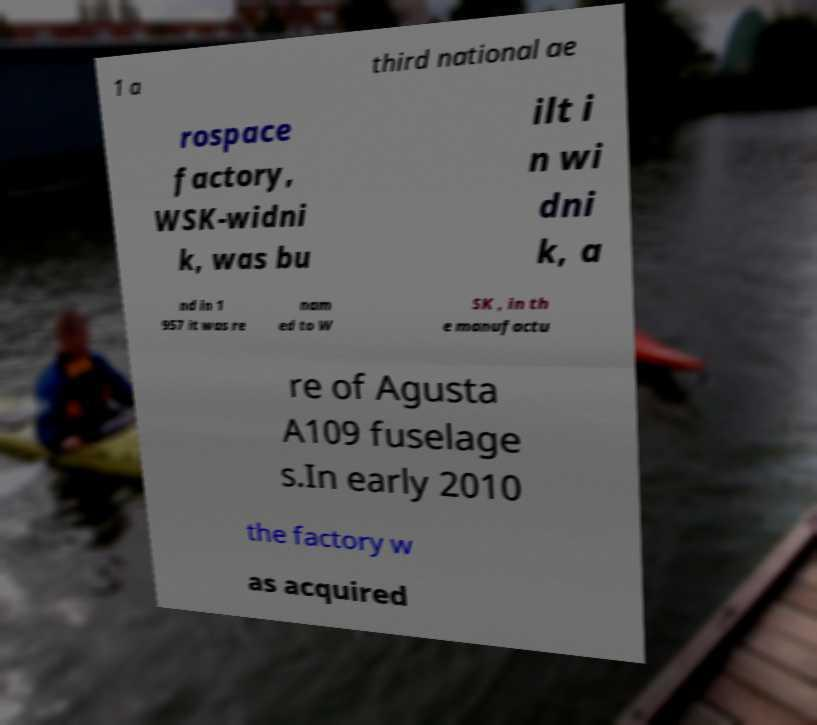Could you extract and type out the text from this image? 1 a third national ae rospace factory, WSK-widni k, was bu ilt i n wi dni k, a nd in 1 957 it was re nam ed to W SK , in th e manufactu re of Agusta A109 fuselage s.In early 2010 the factory w as acquired 